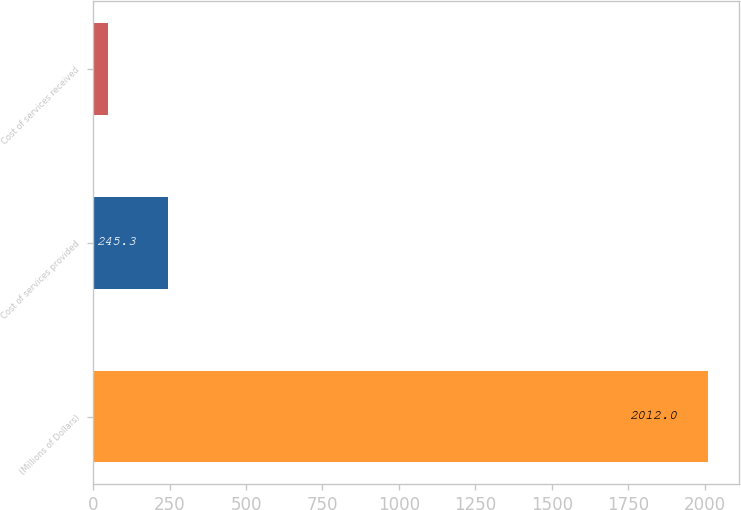Convert chart. <chart><loc_0><loc_0><loc_500><loc_500><bar_chart><fcel>(Millions of Dollars)<fcel>Cost of services provided<fcel>Cost of services received<nl><fcel>2012<fcel>245.3<fcel>49<nl></chart> 